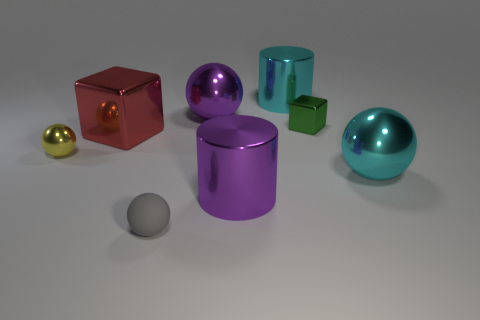Subtract all gray balls. How many balls are left? 3 Subtract all green cubes. How many red cylinders are left? 0 Add 5 large cyan metallic spheres. How many large cyan metallic spheres exist? 6 Add 1 red matte cylinders. How many objects exist? 9 Subtract all cyan balls. How many balls are left? 3 Subtract 0 green cylinders. How many objects are left? 8 Subtract all cylinders. How many objects are left? 6 Subtract 1 cylinders. How many cylinders are left? 1 Subtract all yellow cylinders. Subtract all green spheres. How many cylinders are left? 2 Subtract all yellow metal spheres. Subtract all cyan shiny cylinders. How many objects are left? 6 